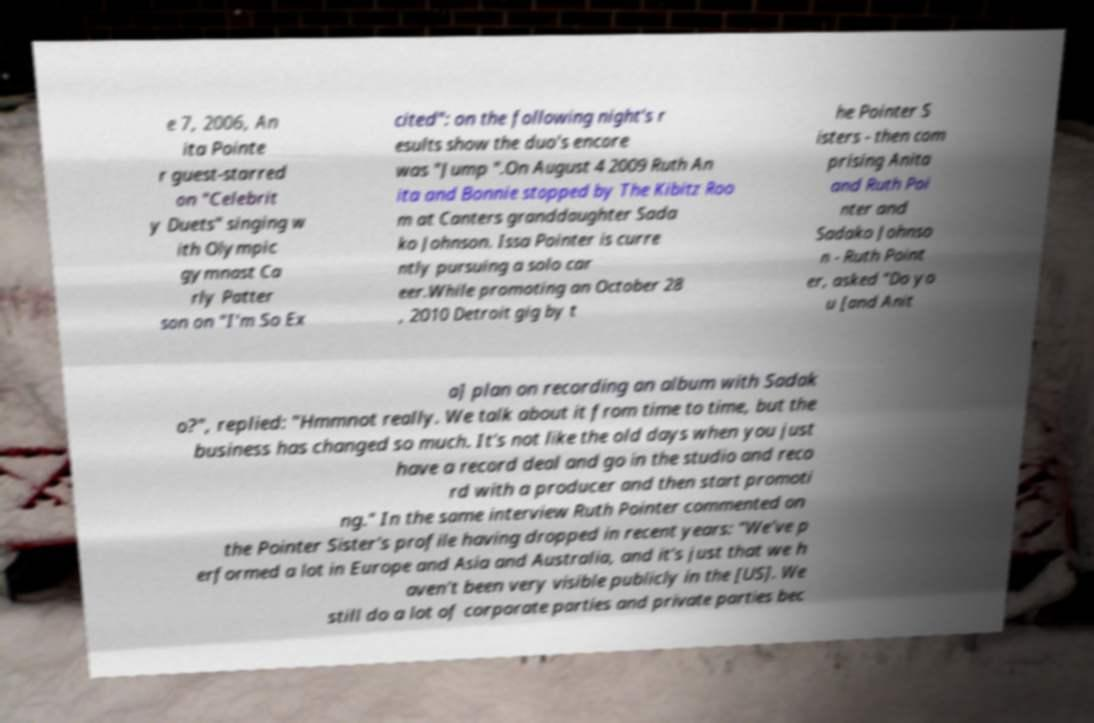I need the written content from this picture converted into text. Can you do that? e 7, 2006, An ita Pointe r guest-starred on "Celebrit y Duets" singing w ith Olympic gymnast Ca rly Patter son on "I'm So Ex cited": on the following night's r esults show the duo's encore was "Jump ".On August 4 2009 Ruth An ita and Bonnie stopped by The Kibitz Roo m at Canters granddaughter Sada ko Johnson. Issa Pointer is curre ntly pursuing a solo car eer.While promoting an October 28 , 2010 Detroit gig by t he Pointer S isters - then com prising Anita and Ruth Poi nter and Sadako Johnso n - Ruth Point er, asked "Do yo u [and Anit a] plan on recording an album with Sadak o?", replied: "Hmmnot really. We talk about it from time to time, but the business has changed so much. It's not like the old days when you just have a record deal and go in the studio and reco rd with a producer and then start promoti ng." In the same interview Ruth Pointer commented on the Pointer Sister's profile having dropped in recent years: "We've p erformed a lot in Europe and Asia and Australia, and it's just that we h aven't been very visible publicly in the [US]. We still do a lot of corporate parties and private parties bec 